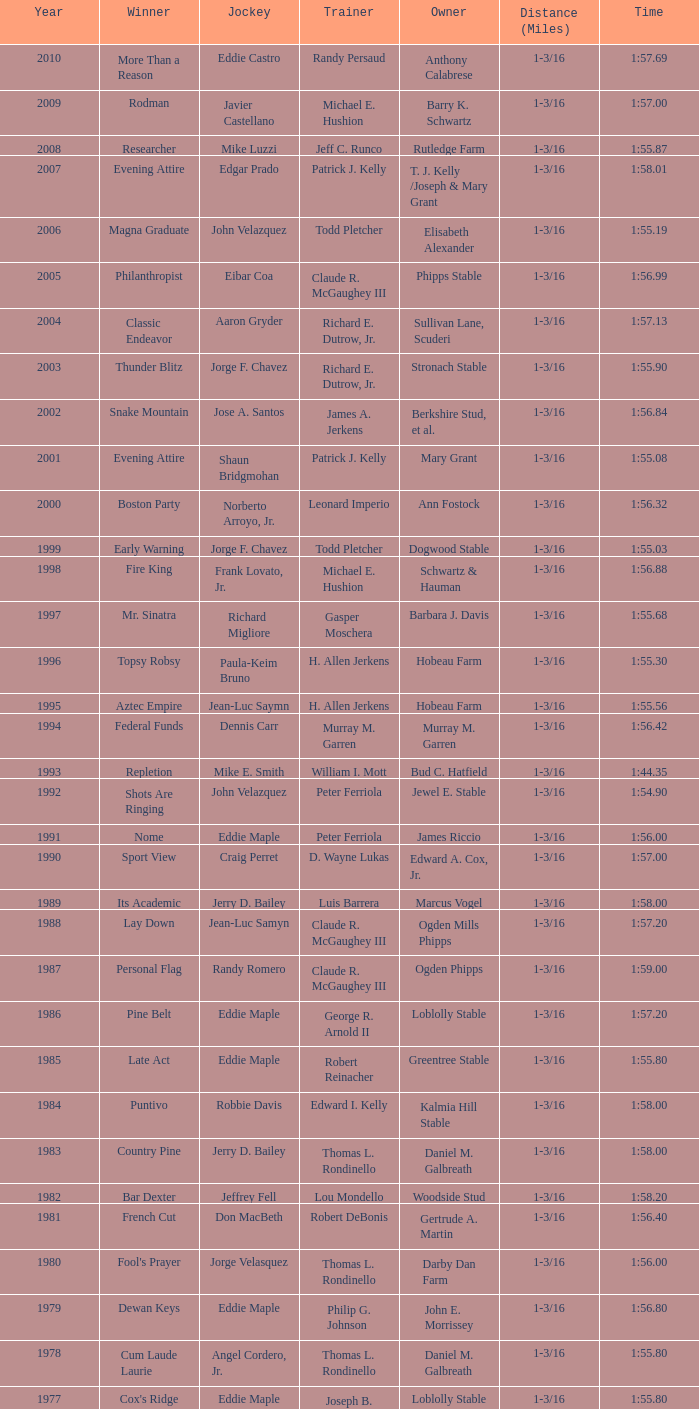Who rode helioptic to win as its jockey? Paul Miller. 